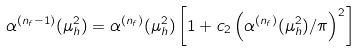Convert formula to latex. <formula><loc_0><loc_0><loc_500><loc_500>\alpha ^ { ( n _ { f } - 1 ) } ( \mu _ { h } ^ { 2 } ) = \alpha ^ { ( n _ { f } ) } ( \mu _ { h } ^ { 2 } ) \left [ 1 + c _ { 2 } \left ( \alpha ^ { ( n _ { f } ) } ( \mu _ { h } ^ { 2 } ) / \pi \right ) ^ { 2 } \right ]</formula> 